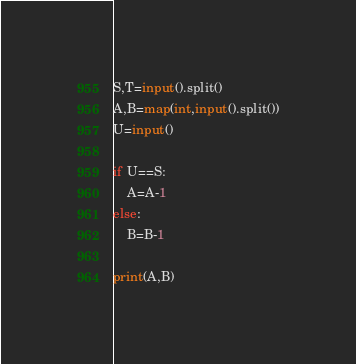Convert code to text. <code><loc_0><loc_0><loc_500><loc_500><_Python_>S,T=input().split()
A,B=map(int,input().split())
U=input()

if U==S:
    A=A-1
else:
    B=B-1

print(A,B)
</code> 